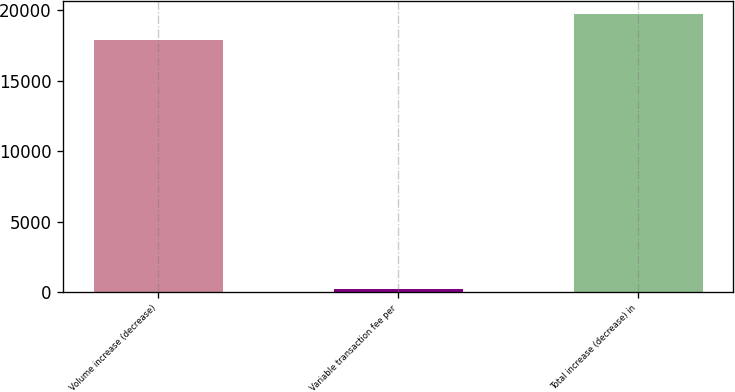Convert chart to OTSL. <chart><loc_0><loc_0><loc_500><loc_500><bar_chart><fcel>Volume increase (decrease)<fcel>Variable transaction fee per<fcel>Total increase (decrease) in<nl><fcel>17901<fcel>236<fcel>19691.1<nl></chart> 